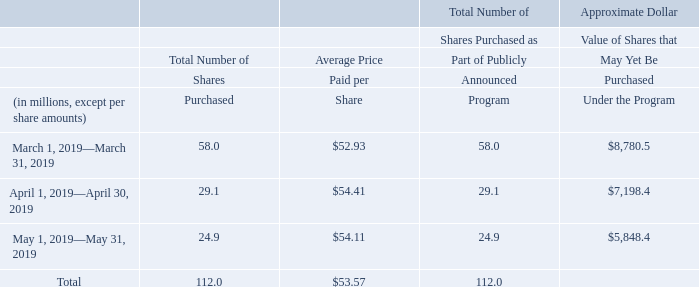Stock Repurchase Program
Our Board of Directors has approved a program for us to repurchase shares of our common stock. On September 17, 2018 and February 15, 2019, we announced that our Board of Directors approved expansions of our stock repurchase program totaling $24.0 billion. As of May 31, 2019, approximately $5.8 billion remained available for stock repurchases pursuant to our stock repurchase program.
Our stock repurchase authorization does not have an expiration date and the pace of our repurchase activity will depend on factors such as our working capital needs, our cash requirements for acquisitions and dividend payments, our debt repayment obligations or repurchases of our debt, our stock price, and economic and market conditions. Our stock repurchases may be effected from time to time through open market purchases or pursuant to a rule 10b5-1 plan. Our stock repurchase program may be accelerated, suspended, delayed or discontinued at any time.
The following table summarizes the stock repurchase activity for the three months ended May 31, 2019 and the approximate dollar value of shares that may yet be purchased pursuant to our stock repurchase program:
What is the average approximate Dollar Value of Shares that May Yet Be Purchased Under the Program from March 1, 2019 to May 31, 2019?
Answer scale should be: million. (8,780.5+7,198.4+5,848.4) / 3 
Answer: 7275.77. How much is the percentage decrease in total number of shares purchased from March 2019 to April 2019?
Answer scale should be: percent. (29.1-58.0)/58.0 
Answer: -49.83. What was the Average Price Paid per Share from March 2019 to April 2019? (52.93*58.0+54.41*29.1)/(58.0+29.1) 
Answer: 53.42. What factors could potentially affect the pace of Oracle’s stock repurchase activities? Our stock repurchase authorization does not have an expiration date and the pace of our repurchase activity will depend on factors such as our working capital needs, our cash requirements for acquisitions and dividend payments, our debt repayment obligations or repurchases of our debt, our stock price, and economic and market conditions. When did Oracle announce the approval of expansions of the stock repurchase program by the Board of Directors? On september 17, 2018 and february 15, 2019, we announced that our board of directors approved expansions of our stock repurchase program totaling $24.0 billion. How does Oracle effect its stock repurchases? Our stock repurchases may be effected from time to time through open market purchases or pursuant to a rule 10b5-1 plan. our stock repurchase program may be accelerated, suspended, delayed or discontinued at any time. 